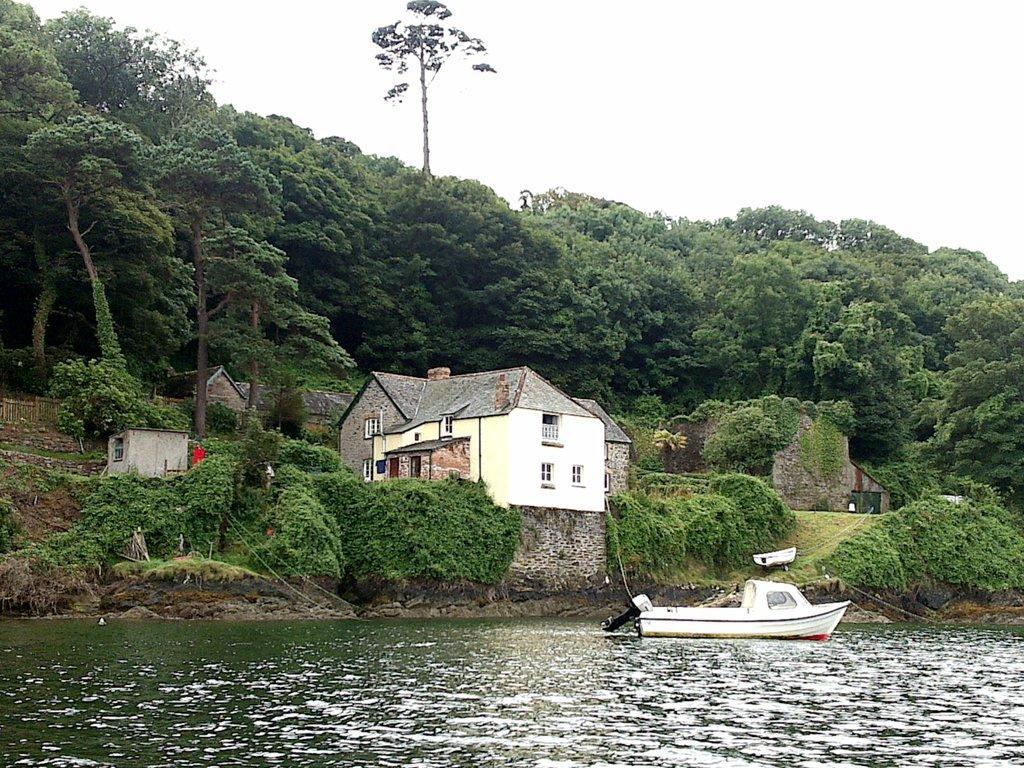In one or two sentences, can you explain what this image depicts? In this image, I can see a boat on the water. This looks like a lake with the water flowing. I can see the houses with the windows. These are the trees and small bushes. This looks like a small hill. 